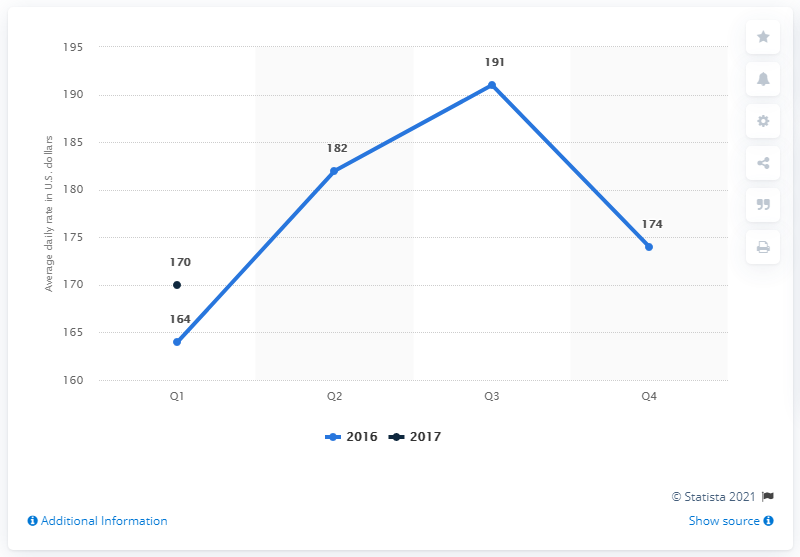List a handful of essential elements in this visual. The average daily rate of hotels in Denver in the United States during the first quarter of 2017 was approximately $170. 